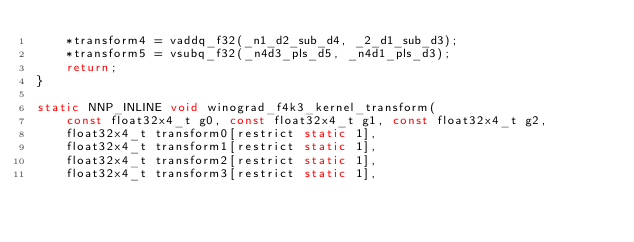<code> <loc_0><loc_0><loc_500><loc_500><_C_>    *transform4 = vaddq_f32(_n1_d2_sub_d4, _2_d1_sub_d3);
    *transform5 = vsubq_f32(_n4d3_pls_d5, _n4d1_pls_d3);
    return;
}

static NNP_INLINE void winograd_f4k3_kernel_transform(
	const float32x4_t g0, const float32x4_t g1, const float32x4_t g2,
	float32x4_t transform0[restrict static 1],
	float32x4_t transform1[restrict static 1],
	float32x4_t transform2[restrict static 1],
	float32x4_t transform3[restrict static 1],</code> 